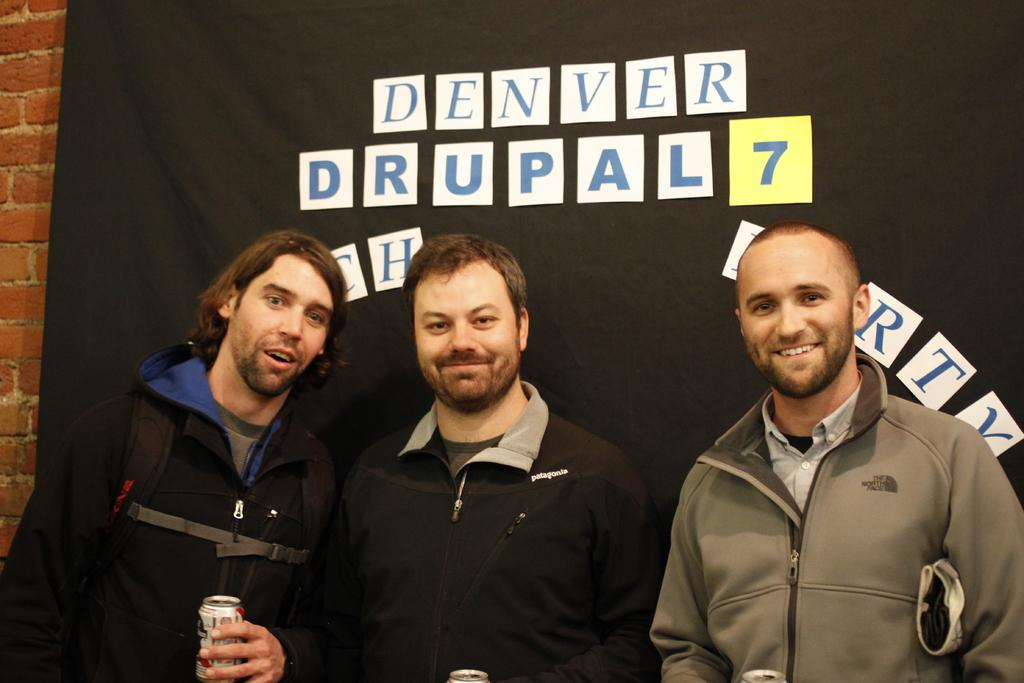<image>
Offer a succinct explanation of the picture presented. Three men are standing in front of a wall stating Denver Drupal 7. 